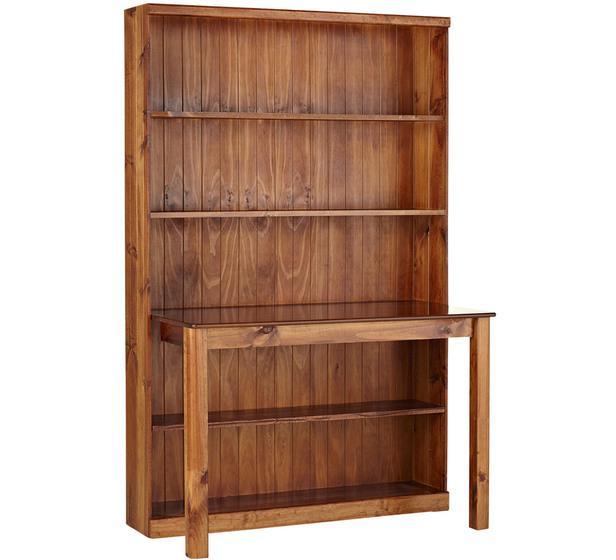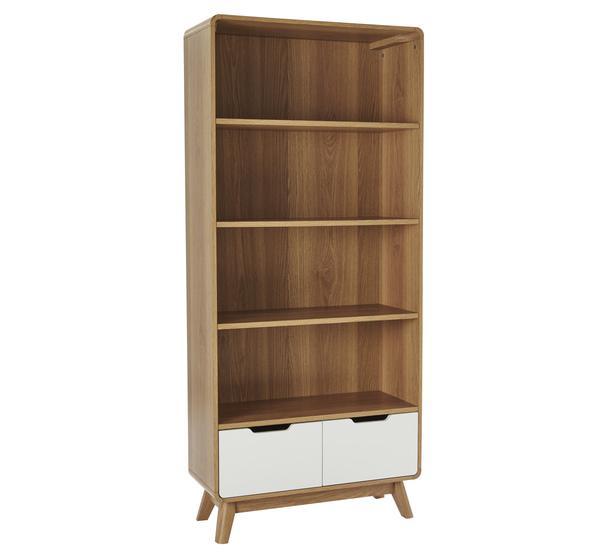The first image is the image on the left, the second image is the image on the right. Given the left and right images, does the statement "One image features an open-backed shelf with a front that angles toward a white wall like a ladder." hold true? Answer yes or no. No. The first image is the image on the left, the second image is the image on the right. Considering the images on both sides, is "A combination desk and shelf unit is built at an angle to a wall, becoming wider as it gets closer to the floor, with a small desk area in the center." valid? Answer yes or no. No. 